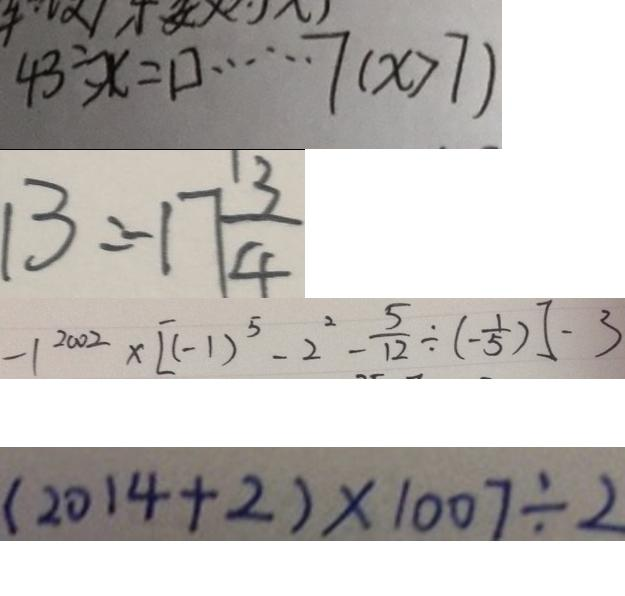Convert formula to latex. <formula><loc_0><loc_0><loc_500><loc_500>4 3 \div x = \square \cdots 7 ( x > 7 ) 
 1 3 = - 1 7 \frac { 1 3 } { 4 } 
 - 1 ^ { 2 0 0 2 } \times [ ( - 1 ) ^ { 5 } - 2 ^ { 2 } - \frac { 5 } { 1 2 } \div ( - \frac { 1 } { 5 } ) ] - 3 
 ( 2 0 1 4 + 2 ) \times 1 0 0 7 \div 2</formula> 